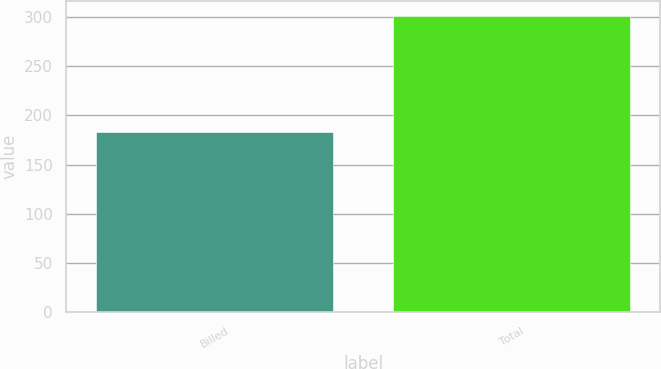<chart> <loc_0><loc_0><loc_500><loc_500><bar_chart><fcel>Billed<fcel>Total<nl><fcel>183<fcel>301<nl></chart> 